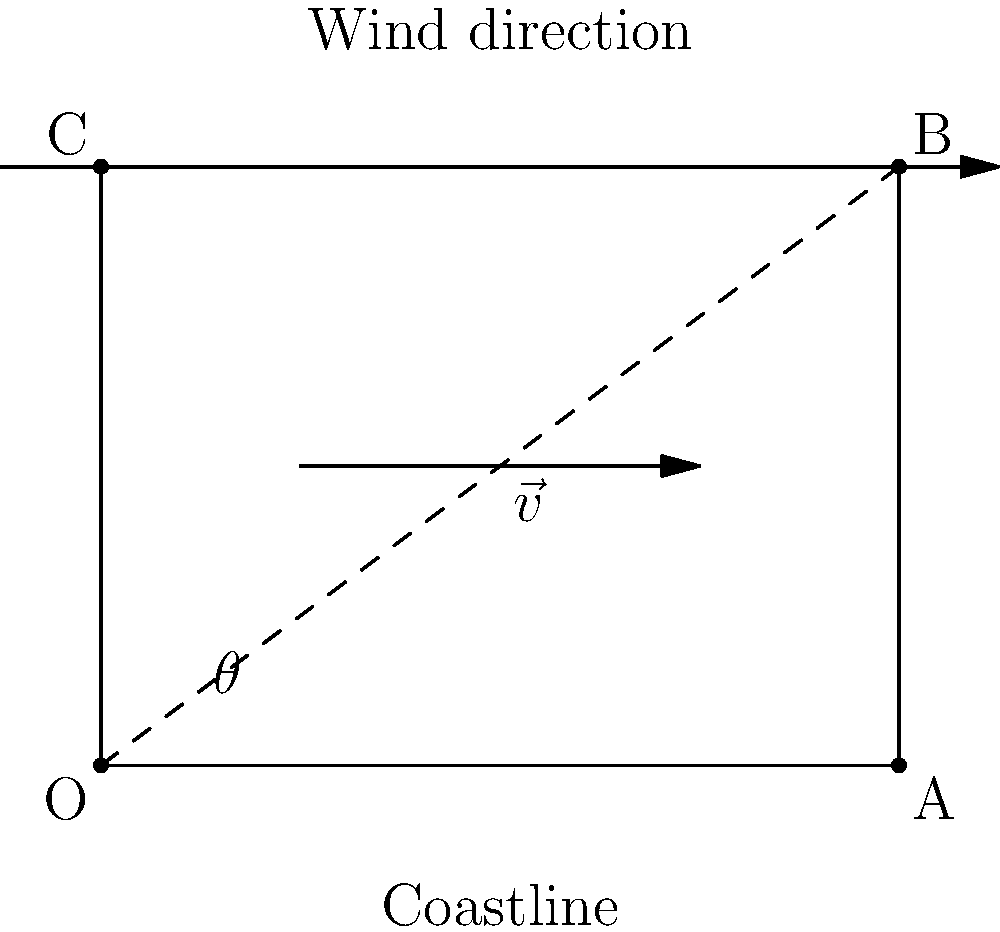In a coastal area, you're tasked with optimizing wind turbine placement. Given a wind vector $\vec{v}$ and the coastline as shown, what component of the wind vector is parallel to the coastline? Express your answer in terms of $\|\vec{v}\|$ and $\theta$. To find the component of the wind vector parallel to the coastline, we need to use vector projection. Here's how:

1) The coastline is represented by the vector $\vec{OA}$.

2) The wind vector $\vec{v}$ makes an angle $\theta$ with the coastline.

3) To find the component parallel to the coastline, we need to project $\vec{v}$ onto $\vec{OA}$.

4) The formula for vector projection is:
   $$\text{proj}_{\vec{OA}}\vec{v} = \|\vec{v}\| \cos\theta$$

5) This gives us the magnitude of the projection. The direction is the same as $\vec{OA}$.

6) Therefore, the component of the wind vector parallel to the coastline is $\|\vec{v}\| \cos\theta$.

This result is particularly relevant for wind turbine placement in coastal areas, as it helps determine how much of the wind's energy can be captured along the coastline.
Answer: $\|\vec{v}\| \cos\theta$ 